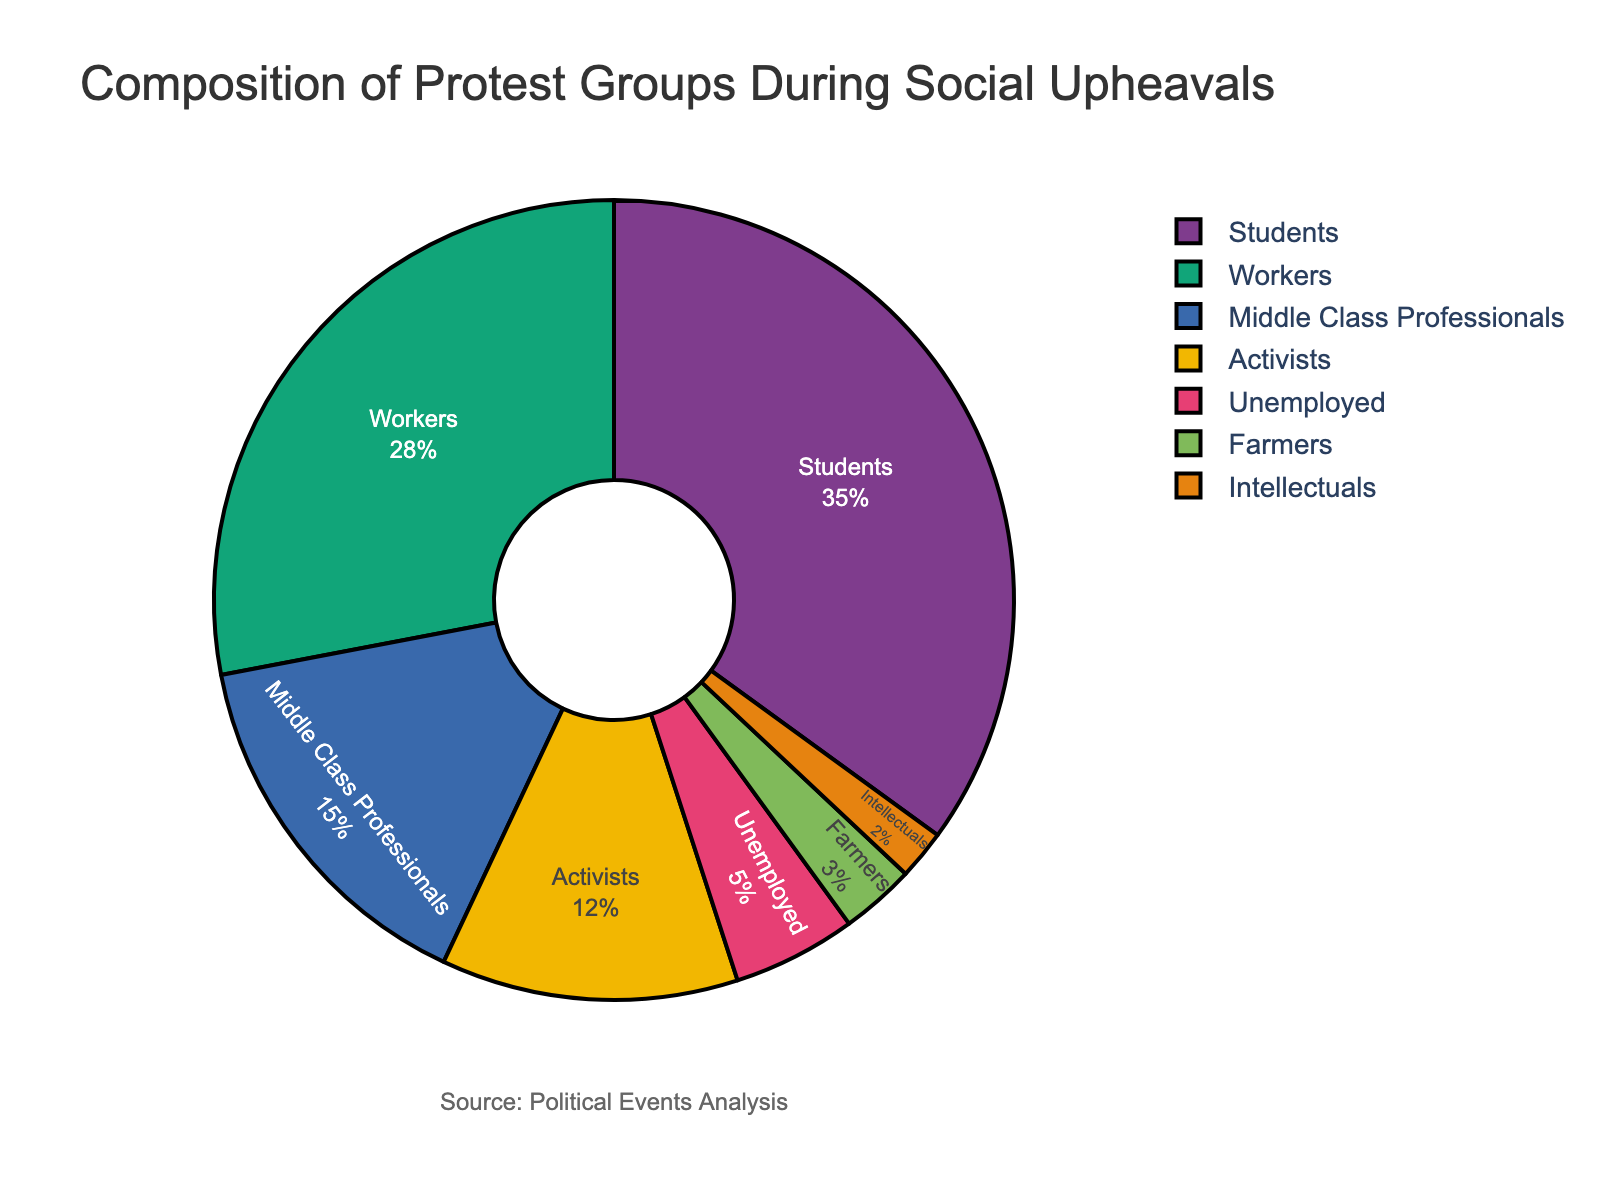which group constitutes the largest portion of protestors? The figure shows percentages for different groups involved in protests. By observing the values in the pie chart, you can identify the group with the highest percentage.
Answer: Students which two groups combined constitute more than 50% of the protestors? By adding the percentages of different groups, you can find pairs that sum up to more than 50%. For example, combining Students (35%) and Workers (28%) gives 63%, which is more than 50%.
Answer: Students and Workers what is the total percentage of protestors made up by Middle Class Professionals, Activists, and Unemployed groups? Add the percentages for Middle Class Professionals (15%), Activists (12%), and Unemployed (5%). The sum is 15 + 12 + 5 = 32%.
Answer: 32% which group constitutes a smaller portion of protestors, Farmers or Intellectuals? The figure shows percentages for different groups. Farmers have 3% and Intellectuals have 2%. Since 2% is less than 3%, Intellectuals constitute a smaller portion.
Answer: Intellectuals how much larger is the Students' portion compared to the Farmers' portion? Subtract the percentage of Farmers (3%) from the percentage of Students (35%). This gives 35 - 3 = 32%.
Answer: 32% if you were to group Farmers and Intellectuals together, what would their combined percentage be? Add the percentages of Farmers (3%) and Intellectuals (2%). The sum is 3 + 2 = 5%.
Answer: 5% comparing Workers and Middle Class Professionals, which group makes up a smaller percentage of the protestors? Workers constitute 28% while Middle Class Professionals constitute 15%. Since 15% is less than 28%, Middle Class Professionals make up a smaller percentage.
Answer: Middle Class Professionals which groups have a percentage below 10%? The groups with percentages below 10% are Unemployed (5%), Farmers (3%), and Intellectuals (2%).
Answer: Unemployed, Farmers, Intellectuals how much larger is the percentage of Activists compared to the percentage of Farmers? Subtract the percentage of Farmers (3%) from the percentage of Activists (12%). This gives 12 - 3 = 9%.
Answer: 9% what percent of the pie chart is made up by groups other than Students and Workers? Subtract the combined percentage of Students (35%) and Workers (28%) from 100%. This gives 100 - (35 + 28) = 100 - 63 = 37%.
Answer: 37% 